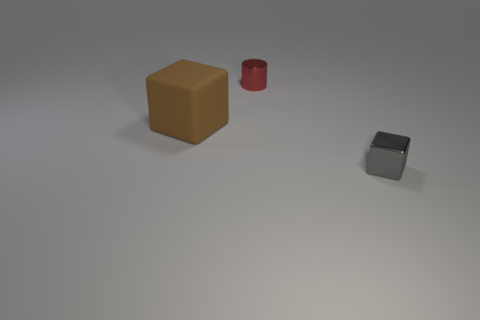Add 1 large matte cubes. How many objects exist? 4 Subtract all cylinders. How many objects are left? 2 Add 2 gray shiny things. How many gray shiny things are left? 3 Add 1 big red blocks. How many big red blocks exist? 1 Subtract 0 red balls. How many objects are left? 3 Subtract all tiny cyan shiny blocks. Subtract all tiny gray shiny blocks. How many objects are left? 2 